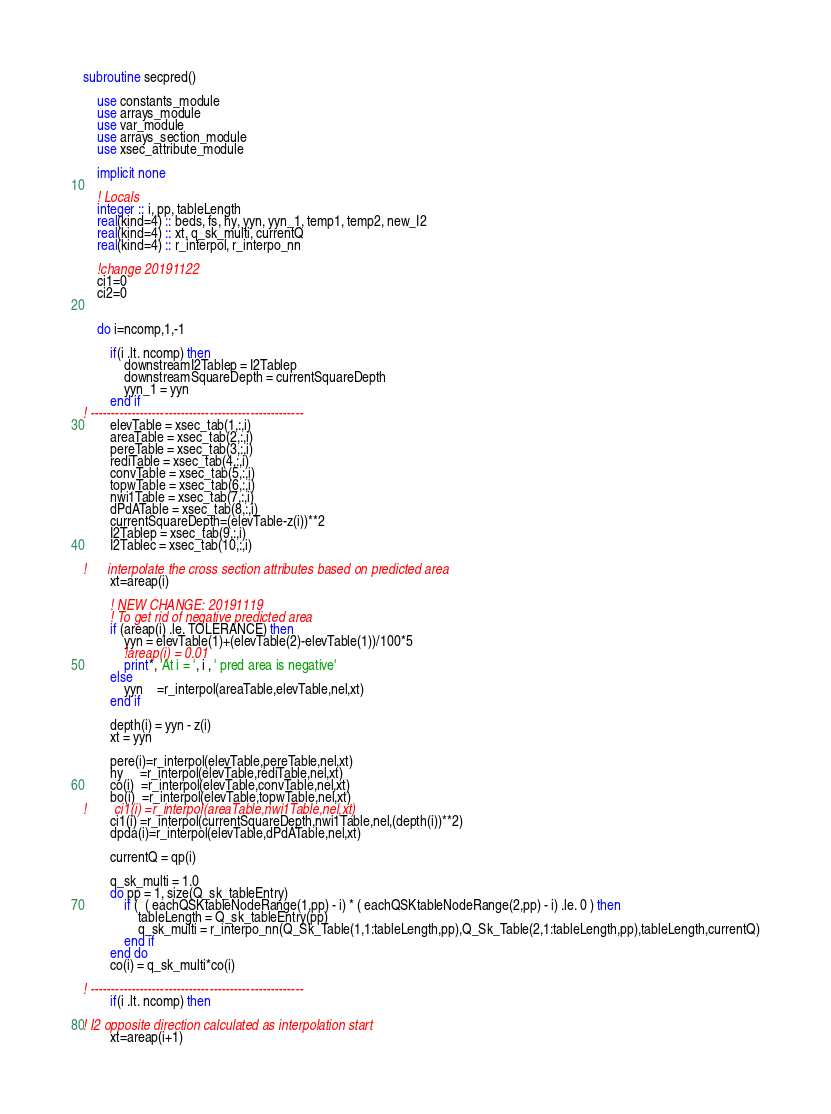<code> <loc_0><loc_0><loc_500><loc_500><_FORTRAN_>subroutine secpred()

    use constants_module
    use arrays_module
    use var_module
    use arrays_section_module
    use xsec_attribute_module

    implicit none

    ! Locals
    integer :: i, pp, tableLength
    real(kind=4) :: beds, fs, hy, yyn, yyn_1, temp1, temp2, new_I2
    real(kind=4) :: xt, q_sk_multi, currentQ
    real(kind=4) :: r_interpol, r_interpo_nn

    !change 20191122
    ci1=0
    ci2=0


    do i=ncomp,1,-1

        if(i .lt. ncomp) then
            downstreamI2Tablep = I2Tablep
            downstreamSquareDepth = currentSquareDepth
            yyn_1 = yyn
        end if
! ----------------------------------------------------
        elevTable = xsec_tab(1,:,i)
        areaTable = xsec_tab(2,:,i)
        pereTable = xsec_tab(3,:,i)
        rediTable = xsec_tab(4,:,i)
        convTable = xsec_tab(5,:,i)
        topwTable = xsec_tab(6,:,i)
        nwi1Table = xsec_tab(7,:,i)
        dPdATable = xsec_tab(8,:,i)
        currentSquareDepth=(elevTable-z(i))**2
        I2Tablep = xsec_tab(9,:,i)
        I2Tablec = xsec_tab(10,:,i)

!      interpolate the cross section attributes based on predicted area
        xt=areap(i)

        ! NEW CHANGE: 20191119
        ! To get rid of negative predicted area
        if (areap(i) .le. TOLERANCE) then
            yyn = elevTable(1)+(elevTable(2)-elevTable(1))/100*5
            !areap(i) = 0.01
            print*, 'At i = ', i , ' pred area is negative'
        else
            yyn    =r_interpol(areaTable,elevTable,nel,xt)
        end if

        depth(i) = yyn - z(i)
        xt = yyn

        pere(i)=r_interpol(elevTable,pereTable,nel,xt)
        hy     =r_interpol(elevTable,rediTable,nel,xt)
        co(i)  =r_interpol(elevTable,convTable,nel,xt)
        bo(i)  =r_interpol(elevTable,topwTable,nel,xt)
!        ci1(i) =r_interpol(areaTable,nwi1Table,nel,xt)
        ci1(i) =r_interpol(currentSquareDepth,nwi1Table,nel,(depth(i))**2)
        dpda(i)=r_interpol(elevTable,dPdATable,nel,xt)

        currentQ = qp(i)

        q_sk_multi = 1.0
        do pp = 1, size(Q_sk_tableEntry)
            if (  ( eachQSKtableNodeRange(1,pp) - i) * ( eachQSKtableNodeRange(2,pp) - i) .le. 0 ) then
				tableLength = Q_sk_tableEntry(pp)
                q_sk_multi = r_interpo_nn(Q_Sk_Table(1,1:tableLength,pp),Q_Sk_Table(2,1:tableLength,pp),tableLength,currentQ)
            end if
        end do
        co(i) = q_sk_multi*co(i)

! ----------------------------------------------------
        if(i .lt. ncomp) then

! I2 opposite direction calculated as interpolation start
        xt=areap(i+1)</code> 